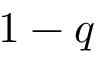<formula> <loc_0><loc_0><loc_500><loc_500>1 - q</formula> 